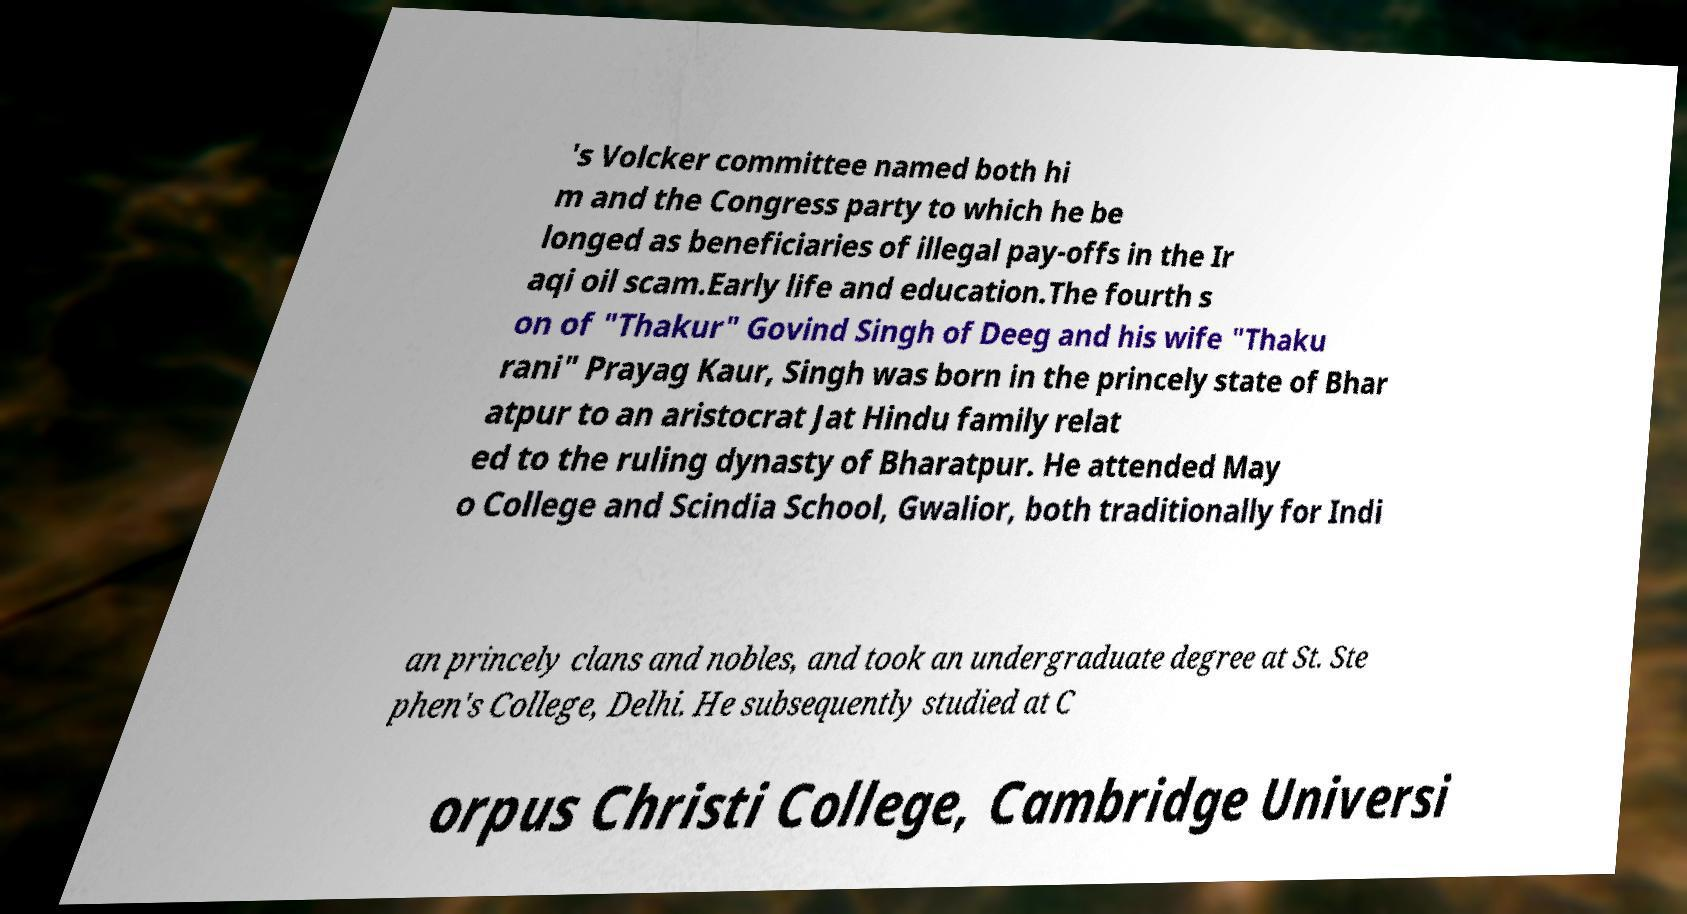Could you extract and type out the text from this image? 's Volcker committee named both hi m and the Congress party to which he be longed as beneficiaries of illegal pay-offs in the Ir aqi oil scam.Early life and education.The fourth s on of "Thakur" Govind Singh of Deeg and his wife "Thaku rani" Prayag Kaur, Singh was born in the princely state of Bhar atpur to an aristocrat Jat Hindu family relat ed to the ruling dynasty of Bharatpur. He attended May o College and Scindia School, Gwalior, both traditionally for Indi an princely clans and nobles, and took an undergraduate degree at St. Ste phen's College, Delhi. He subsequently studied at C orpus Christi College, Cambridge Universi 